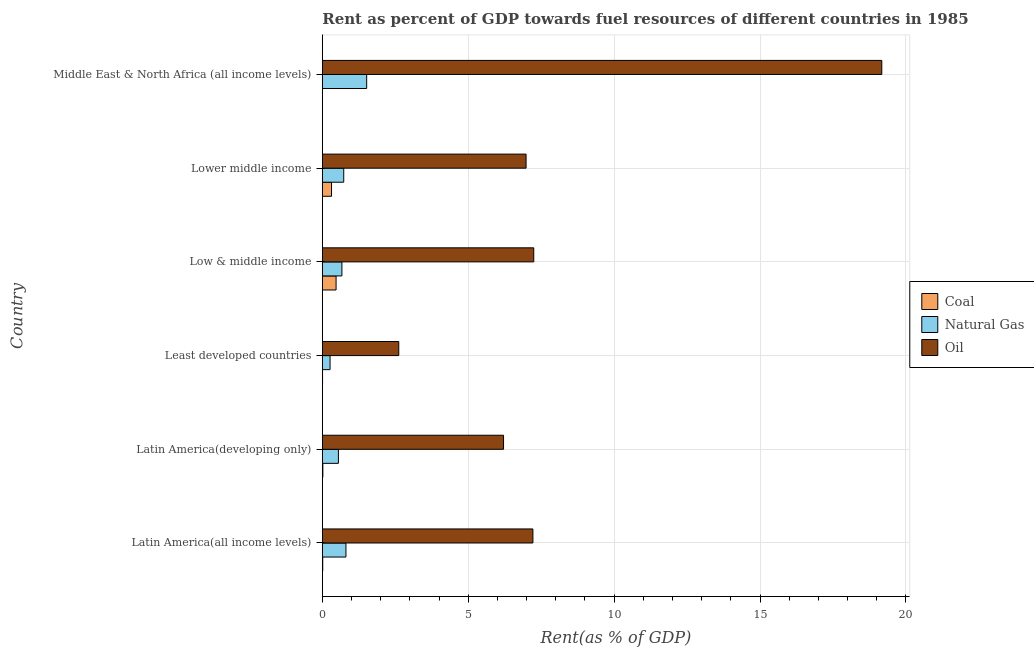Are the number of bars per tick equal to the number of legend labels?
Provide a succinct answer. Yes. Are the number of bars on each tick of the Y-axis equal?
Ensure brevity in your answer.  Yes. How many bars are there on the 5th tick from the top?
Offer a very short reply. 3. What is the label of the 5th group of bars from the top?
Provide a short and direct response. Latin America(developing only). What is the rent towards oil in Middle East & North Africa (all income levels)?
Keep it short and to the point. 19.17. Across all countries, what is the maximum rent towards coal?
Offer a very short reply. 0.47. Across all countries, what is the minimum rent towards coal?
Your response must be concise. 0. In which country was the rent towards natural gas maximum?
Offer a very short reply. Middle East & North Africa (all income levels). In which country was the rent towards oil minimum?
Provide a short and direct response. Least developed countries. What is the total rent towards coal in the graph?
Offer a terse response. 0.83. What is the difference between the rent towards oil in Latin America(all income levels) and that in Lower middle income?
Make the answer very short. 0.23. What is the difference between the rent towards natural gas in Low & middle income and the rent towards oil in Least developed countries?
Make the answer very short. -1.95. What is the average rent towards coal per country?
Your response must be concise. 0.14. What is the difference between the rent towards natural gas and rent towards coal in Latin America(developing only)?
Make the answer very short. 0.53. What is the ratio of the rent towards coal in Latin America(developing only) to that in Low & middle income?
Your answer should be compact. 0.04. Is the rent towards coal in Latin America(all income levels) less than that in Low & middle income?
Your answer should be very brief. Yes. Is the difference between the rent towards natural gas in Latin America(all income levels) and Lower middle income greater than the difference between the rent towards oil in Latin America(all income levels) and Lower middle income?
Provide a succinct answer. No. What is the difference between the highest and the second highest rent towards coal?
Make the answer very short. 0.16. In how many countries, is the rent towards coal greater than the average rent towards coal taken over all countries?
Your answer should be compact. 2. Is the sum of the rent towards coal in Latin America(all income levels) and Low & middle income greater than the maximum rent towards oil across all countries?
Your answer should be very brief. No. What does the 2nd bar from the top in Low & middle income represents?
Offer a terse response. Natural Gas. What does the 2nd bar from the bottom in Least developed countries represents?
Offer a very short reply. Natural Gas. How many bars are there?
Provide a succinct answer. 18. Are all the bars in the graph horizontal?
Offer a very short reply. Yes. How many countries are there in the graph?
Provide a short and direct response. 6. What is the difference between two consecutive major ticks on the X-axis?
Offer a terse response. 5. What is the title of the graph?
Your answer should be very brief. Rent as percent of GDP towards fuel resources of different countries in 1985. Does "Transport equipments" appear as one of the legend labels in the graph?
Ensure brevity in your answer.  No. What is the label or title of the X-axis?
Your response must be concise. Rent(as % of GDP). What is the label or title of the Y-axis?
Ensure brevity in your answer.  Country. What is the Rent(as % of GDP) in Coal in Latin America(all income levels)?
Give a very brief answer. 0.01. What is the Rent(as % of GDP) of Natural Gas in Latin America(all income levels)?
Your response must be concise. 0.81. What is the Rent(as % of GDP) of Oil in Latin America(all income levels)?
Your answer should be compact. 7.22. What is the Rent(as % of GDP) of Coal in Latin America(developing only)?
Give a very brief answer. 0.02. What is the Rent(as % of GDP) in Natural Gas in Latin America(developing only)?
Provide a succinct answer. 0.55. What is the Rent(as % of GDP) of Oil in Latin America(developing only)?
Ensure brevity in your answer.  6.21. What is the Rent(as % of GDP) of Coal in Least developed countries?
Your answer should be compact. 0.01. What is the Rent(as % of GDP) in Natural Gas in Least developed countries?
Ensure brevity in your answer.  0.27. What is the Rent(as % of GDP) of Oil in Least developed countries?
Offer a very short reply. 2.62. What is the Rent(as % of GDP) of Coal in Low & middle income?
Your response must be concise. 0.47. What is the Rent(as % of GDP) of Natural Gas in Low & middle income?
Offer a very short reply. 0.67. What is the Rent(as % of GDP) of Oil in Low & middle income?
Your answer should be compact. 7.25. What is the Rent(as % of GDP) in Coal in Lower middle income?
Offer a very short reply. 0.32. What is the Rent(as % of GDP) in Natural Gas in Lower middle income?
Provide a short and direct response. 0.73. What is the Rent(as % of GDP) of Oil in Lower middle income?
Give a very brief answer. 6.98. What is the Rent(as % of GDP) of Coal in Middle East & North Africa (all income levels)?
Your response must be concise. 0. What is the Rent(as % of GDP) in Natural Gas in Middle East & North Africa (all income levels)?
Keep it short and to the point. 1.52. What is the Rent(as % of GDP) in Oil in Middle East & North Africa (all income levels)?
Give a very brief answer. 19.17. Across all countries, what is the maximum Rent(as % of GDP) in Coal?
Your answer should be compact. 0.47. Across all countries, what is the maximum Rent(as % of GDP) of Natural Gas?
Provide a short and direct response. 1.52. Across all countries, what is the maximum Rent(as % of GDP) of Oil?
Give a very brief answer. 19.17. Across all countries, what is the minimum Rent(as % of GDP) in Coal?
Provide a succinct answer. 0. Across all countries, what is the minimum Rent(as % of GDP) of Natural Gas?
Offer a terse response. 0.27. Across all countries, what is the minimum Rent(as % of GDP) of Oil?
Your response must be concise. 2.62. What is the total Rent(as % of GDP) of Coal in the graph?
Offer a very short reply. 0.83. What is the total Rent(as % of GDP) of Natural Gas in the graph?
Give a very brief answer. 4.55. What is the total Rent(as % of GDP) of Oil in the graph?
Keep it short and to the point. 49.45. What is the difference between the Rent(as % of GDP) of Coal in Latin America(all income levels) and that in Latin America(developing only)?
Offer a very short reply. -0. What is the difference between the Rent(as % of GDP) in Natural Gas in Latin America(all income levels) and that in Latin America(developing only)?
Give a very brief answer. 0.26. What is the difference between the Rent(as % of GDP) of Oil in Latin America(all income levels) and that in Latin America(developing only)?
Provide a short and direct response. 1.01. What is the difference between the Rent(as % of GDP) of Coal in Latin America(all income levels) and that in Least developed countries?
Keep it short and to the point. 0.01. What is the difference between the Rent(as % of GDP) in Natural Gas in Latin America(all income levels) and that in Least developed countries?
Give a very brief answer. 0.54. What is the difference between the Rent(as % of GDP) in Oil in Latin America(all income levels) and that in Least developed countries?
Keep it short and to the point. 4.6. What is the difference between the Rent(as % of GDP) in Coal in Latin America(all income levels) and that in Low & middle income?
Make the answer very short. -0.46. What is the difference between the Rent(as % of GDP) in Natural Gas in Latin America(all income levels) and that in Low & middle income?
Your answer should be compact. 0.14. What is the difference between the Rent(as % of GDP) of Oil in Latin America(all income levels) and that in Low & middle income?
Offer a terse response. -0.03. What is the difference between the Rent(as % of GDP) in Coal in Latin America(all income levels) and that in Lower middle income?
Provide a short and direct response. -0.3. What is the difference between the Rent(as % of GDP) of Natural Gas in Latin America(all income levels) and that in Lower middle income?
Provide a short and direct response. 0.08. What is the difference between the Rent(as % of GDP) of Oil in Latin America(all income levels) and that in Lower middle income?
Give a very brief answer. 0.23. What is the difference between the Rent(as % of GDP) of Coal in Latin America(all income levels) and that in Middle East & North Africa (all income levels)?
Provide a short and direct response. 0.01. What is the difference between the Rent(as % of GDP) in Natural Gas in Latin America(all income levels) and that in Middle East & North Africa (all income levels)?
Keep it short and to the point. -0.71. What is the difference between the Rent(as % of GDP) in Oil in Latin America(all income levels) and that in Middle East & North Africa (all income levels)?
Your response must be concise. -11.96. What is the difference between the Rent(as % of GDP) in Coal in Latin America(developing only) and that in Least developed countries?
Provide a succinct answer. 0.01. What is the difference between the Rent(as % of GDP) in Natural Gas in Latin America(developing only) and that in Least developed countries?
Offer a terse response. 0.29. What is the difference between the Rent(as % of GDP) in Oil in Latin America(developing only) and that in Least developed countries?
Give a very brief answer. 3.59. What is the difference between the Rent(as % of GDP) of Coal in Latin America(developing only) and that in Low & middle income?
Your response must be concise. -0.45. What is the difference between the Rent(as % of GDP) in Natural Gas in Latin America(developing only) and that in Low & middle income?
Provide a succinct answer. -0.12. What is the difference between the Rent(as % of GDP) in Oil in Latin America(developing only) and that in Low & middle income?
Keep it short and to the point. -1.03. What is the difference between the Rent(as % of GDP) in Coal in Latin America(developing only) and that in Lower middle income?
Give a very brief answer. -0.3. What is the difference between the Rent(as % of GDP) of Natural Gas in Latin America(developing only) and that in Lower middle income?
Offer a very short reply. -0.18. What is the difference between the Rent(as % of GDP) of Oil in Latin America(developing only) and that in Lower middle income?
Ensure brevity in your answer.  -0.77. What is the difference between the Rent(as % of GDP) in Coal in Latin America(developing only) and that in Middle East & North Africa (all income levels)?
Keep it short and to the point. 0.01. What is the difference between the Rent(as % of GDP) of Natural Gas in Latin America(developing only) and that in Middle East & North Africa (all income levels)?
Give a very brief answer. -0.97. What is the difference between the Rent(as % of GDP) of Oil in Latin America(developing only) and that in Middle East & North Africa (all income levels)?
Your response must be concise. -12.96. What is the difference between the Rent(as % of GDP) of Coal in Least developed countries and that in Low & middle income?
Offer a very short reply. -0.46. What is the difference between the Rent(as % of GDP) of Natural Gas in Least developed countries and that in Low & middle income?
Ensure brevity in your answer.  -0.41. What is the difference between the Rent(as % of GDP) in Oil in Least developed countries and that in Low & middle income?
Your answer should be very brief. -4.63. What is the difference between the Rent(as % of GDP) of Coal in Least developed countries and that in Lower middle income?
Make the answer very short. -0.31. What is the difference between the Rent(as % of GDP) in Natural Gas in Least developed countries and that in Lower middle income?
Ensure brevity in your answer.  -0.47. What is the difference between the Rent(as % of GDP) of Oil in Least developed countries and that in Lower middle income?
Offer a very short reply. -4.36. What is the difference between the Rent(as % of GDP) of Coal in Least developed countries and that in Middle East & North Africa (all income levels)?
Give a very brief answer. 0. What is the difference between the Rent(as % of GDP) in Natural Gas in Least developed countries and that in Middle East & North Africa (all income levels)?
Keep it short and to the point. -1.25. What is the difference between the Rent(as % of GDP) in Oil in Least developed countries and that in Middle East & North Africa (all income levels)?
Your answer should be compact. -16.55. What is the difference between the Rent(as % of GDP) in Coal in Low & middle income and that in Lower middle income?
Offer a very short reply. 0.16. What is the difference between the Rent(as % of GDP) in Natural Gas in Low & middle income and that in Lower middle income?
Your answer should be compact. -0.06. What is the difference between the Rent(as % of GDP) of Oil in Low & middle income and that in Lower middle income?
Offer a very short reply. 0.26. What is the difference between the Rent(as % of GDP) of Coal in Low & middle income and that in Middle East & North Africa (all income levels)?
Keep it short and to the point. 0.47. What is the difference between the Rent(as % of GDP) of Natural Gas in Low & middle income and that in Middle East & North Africa (all income levels)?
Give a very brief answer. -0.85. What is the difference between the Rent(as % of GDP) in Oil in Low & middle income and that in Middle East & North Africa (all income levels)?
Provide a succinct answer. -11.93. What is the difference between the Rent(as % of GDP) in Coal in Lower middle income and that in Middle East & North Africa (all income levels)?
Give a very brief answer. 0.31. What is the difference between the Rent(as % of GDP) in Natural Gas in Lower middle income and that in Middle East & North Africa (all income levels)?
Give a very brief answer. -0.79. What is the difference between the Rent(as % of GDP) of Oil in Lower middle income and that in Middle East & North Africa (all income levels)?
Provide a short and direct response. -12.19. What is the difference between the Rent(as % of GDP) in Coal in Latin America(all income levels) and the Rent(as % of GDP) in Natural Gas in Latin America(developing only)?
Offer a terse response. -0.54. What is the difference between the Rent(as % of GDP) of Coal in Latin America(all income levels) and the Rent(as % of GDP) of Oil in Latin America(developing only)?
Make the answer very short. -6.2. What is the difference between the Rent(as % of GDP) in Natural Gas in Latin America(all income levels) and the Rent(as % of GDP) in Oil in Latin America(developing only)?
Offer a very short reply. -5.4. What is the difference between the Rent(as % of GDP) in Coal in Latin America(all income levels) and the Rent(as % of GDP) in Natural Gas in Least developed countries?
Offer a very short reply. -0.25. What is the difference between the Rent(as % of GDP) in Coal in Latin America(all income levels) and the Rent(as % of GDP) in Oil in Least developed countries?
Your response must be concise. -2.61. What is the difference between the Rent(as % of GDP) in Natural Gas in Latin America(all income levels) and the Rent(as % of GDP) in Oil in Least developed countries?
Provide a short and direct response. -1.81. What is the difference between the Rent(as % of GDP) of Coal in Latin America(all income levels) and the Rent(as % of GDP) of Natural Gas in Low & middle income?
Offer a terse response. -0.66. What is the difference between the Rent(as % of GDP) in Coal in Latin America(all income levels) and the Rent(as % of GDP) in Oil in Low & middle income?
Make the answer very short. -7.23. What is the difference between the Rent(as % of GDP) in Natural Gas in Latin America(all income levels) and the Rent(as % of GDP) in Oil in Low & middle income?
Your response must be concise. -6.44. What is the difference between the Rent(as % of GDP) of Coal in Latin America(all income levels) and the Rent(as % of GDP) of Natural Gas in Lower middle income?
Provide a succinct answer. -0.72. What is the difference between the Rent(as % of GDP) in Coal in Latin America(all income levels) and the Rent(as % of GDP) in Oil in Lower middle income?
Provide a short and direct response. -6.97. What is the difference between the Rent(as % of GDP) of Natural Gas in Latin America(all income levels) and the Rent(as % of GDP) of Oil in Lower middle income?
Offer a very short reply. -6.17. What is the difference between the Rent(as % of GDP) in Coal in Latin America(all income levels) and the Rent(as % of GDP) in Natural Gas in Middle East & North Africa (all income levels)?
Make the answer very short. -1.51. What is the difference between the Rent(as % of GDP) in Coal in Latin America(all income levels) and the Rent(as % of GDP) in Oil in Middle East & North Africa (all income levels)?
Make the answer very short. -19.16. What is the difference between the Rent(as % of GDP) in Natural Gas in Latin America(all income levels) and the Rent(as % of GDP) in Oil in Middle East & North Africa (all income levels)?
Give a very brief answer. -18.36. What is the difference between the Rent(as % of GDP) in Coal in Latin America(developing only) and the Rent(as % of GDP) in Natural Gas in Least developed countries?
Your response must be concise. -0.25. What is the difference between the Rent(as % of GDP) of Coal in Latin America(developing only) and the Rent(as % of GDP) of Oil in Least developed countries?
Provide a succinct answer. -2.6. What is the difference between the Rent(as % of GDP) in Natural Gas in Latin America(developing only) and the Rent(as % of GDP) in Oil in Least developed countries?
Ensure brevity in your answer.  -2.07. What is the difference between the Rent(as % of GDP) in Coal in Latin America(developing only) and the Rent(as % of GDP) in Natural Gas in Low & middle income?
Provide a succinct answer. -0.65. What is the difference between the Rent(as % of GDP) of Coal in Latin America(developing only) and the Rent(as % of GDP) of Oil in Low & middle income?
Provide a succinct answer. -7.23. What is the difference between the Rent(as % of GDP) in Natural Gas in Latin America(developing only) and the Rent(as % of GDP) in Oil in Low & middle income?
Keep it short and to the point. -6.69. What is the difference between the Rent(as % of GDP) in Coal in Latin America(developing only) and the Rent(as % of GDP) in Natural Gas in Lower middle income?
Ensure brevity in your answer.  -0.72. What is the difference between the Rent(as % of GDP) in Coal in Latin America(developing only) and the Rent(as % of GDP) in Oil in Lower middle income?
Provide a succinct answer. -6.96. What is the difference between the Rent(as % of GDP) of Natural Gas in Latin America(developing only) and the Rent(as % of GDP) of Oil in Lower middle income?
Offer a very short reply. -6.43. What is the difference between the Rent(as % of GDP) of Coal in Latin America(developing only) and the Rent(as % of GDP) of Natural Gas in Middle East & North Africa (all income levels)?
Offer a terse response. -1.5. What is the difference between the Rent(as % of GDP) in Coal in Latin America(developing only) and the Rent(as % of GDP) in Oil in Middle East & North Africa (all income levels)?
Your answer should be very brief. -19.15. What is the difference between the Rent(as % of GDP) of Natural Gas in Latin America(developing only) and the Rent(as % of GDP) of Oil in Middle East & North Africa (all income levels)?
Make the answer very short. -18.62. What is the difference between the Rent(as % of GDP) of Coal in Least developed countries and the Rent(as % of GDP) of Natural Gas in Low & middle income?
Give a very brief answer. -0.66. What is the difference between the Rent(as % of GDP) of Coal in Least developed countries and the Rent(as % of GDP) of Oil in Low & middle income?
Your response must be concise. -7.24. What is the difference between the Rent(as % of GDP) in Natural Gas in Least developed countries and the Rent(as % of GDP) in Oil in Low & middle income?
Your response must be concise. -6.98. What is the difference between the Rent(as % of GDP) of Coal in Least developed countries and the Rent(as % of GDP) of Natural Gas in Lower middle income?
Offer a very short reply. -0.73. What is the difference between the Rent(as % of GDP) in Coal in Least developed countries and the Rent(as % of GDP) in Oil in Lower middle income?
Provide a succinct answer. -6.97. What is the difference between the Rent(as % of GDP) in Natural Gas in Least developed countries and the Rent(as % of GDP) in Oil in Lower middle income?
Offer a very short reply. -6.72. What is the difference between the Rent(as % of GDP) in Coal in Least developed countries and the Rent(as % of GDP) in Natural Gas in Middle East & North Africa (all income levels)?
Provide a short and direct response. -1.51. What is the difference between the Rent(as % of GDP) in Coal in Least developed countries and the Rent(as % of GDP) in Oil in Middle East & North Africa (all income levels)?
Give a very brief answer. -19.17. What is the difference between the Rent(as % of GDP) of Natural Gas in Least developed countries and the Rent(as % of GDP) of Oil in Middle East & North Africa (all income levels)?
Offer a very short reply. -18.91. What is the difference between the Rent(as % of GDP) of Coal in Low & middle income and the Rent(as % of GDP) of Natural Gas in Lower middle income?
Provide a short and direct response. -0.26. What is the difference between the Rent(as % of GDP) in Coal in Low & middle income and the Rent(as % of GDP) in Oil in Lower middle income?
Provide a succinct answer. -6.51. What is the difference between the Rent(as % of GDP) in Natural Gas in Low & middle income and the Rent(as % of GDP) in Oil in Lower middle income?
Offer a very short reply. -6.31. What is the difference between the Rent(as % of GDP) of Coal in Low & middle income and the Rent(as % of GDP) of Natural Gas in Middle East & North Africa (all income levels)?
Your response must be concise. -1.05. What is the difference between the Rent(as % of GDP) of Coal in Low & middle income and the Rent(as % of GDP) of Oil in Middle East & North Africa (all income levels)?
Offer a terse response. -18.7. What is the difference between the Rent(as % of GDP) of Natural Gas in Low & middle income and the Rent(as % of GDP) of Oil in Middle East & North Africa (all income levels)?
Your answer should be very brief. -18.5. What is the difference between the Rent(as % of GDP) in Coal in Lower middle income and the Rent(as % of GDP) in Natural Gas in Middle East & North Africa (all income levels)?
Provide a short and direct response. -1.2. What is the difference between the Rent(as % of GDP) of Coal in Lower middle income and the Rent(as % of GDP) of Oil in Middle East & North Africa (all income levels)?
Offer a very short reply. -18.86. What is the difference between the Rent(as % of GDP) in Natural Gas in Lower middle income and the Rent(as % of GDP) in Oil in Middle East & North Africa (all income levels)?
Your answer should be compact. -18.44. What is the average Rent(as % of GDP) in Coal per country?
Give a very brief answer. 0.14. What is the average Rent(as % of GDP) in Natural Gas per country?
Give a very brief answer. 0.76. What is the average Rent(as % of GDP) in Oil per country?
Offer a very short reply. 8.24. What is the difference between the Rent(as % of GDP) in Coal and Rent(as % of GDP) in Natural Gas in Latin America(all income levels)?
Give a very brief answer. -0.8. What is the difference between the Rent(as % of GDP) of Coal and Rent(as % of GDP) of Oil in Latin America(all income levels)?
Keep it short and to the point. -7.2. What is the difference between the Rent(as % of GDP) of Natural Gas and Rent(as % of GDP) of Oil in Latin America(all income levels)?
Your answer should be very brief. -6.41. What is the difference between the Rent(as % of GDP) of Coal and Rent(as % of GDP) of Natural Gas in Latin America(developing only)?
Make the answer very short. -0.53. What is the difference between the Rent(as % of GDP) in Coal and Rent(as % of GDP) in Oil in Latin America(developing only)?
Offer a very short reply. -6.19. What is the difference between the Rent(as % of GDP) of Natural Gas and Rent(as % of GDP) of Oil in Latin America(developing only)?
Keep it short and to the point. -5.66. What is the difference between the Rent(as % of GDP) in Coal and Rent(as % of GDP) in Natural Gas in Least developed countries?
Make the answer very short. -0.26. What is the difference between the Rent(as % of GDP) of Coal and Rent(as % of GDP) of Oil in Least developed countries?
Your answer should be compact. -2.61. What is the difference between the Rent(as % of GDP) of Natural Gas and Rent(as % of GDP) of Oil in Least developed countries?
Give a very brief answer. -2.35. What is the difference between the Rent(as % of GDP) in Coal and Rent(as % of GDP) in Natural Gas in Low & middle income?
Keep it short and to the point. -0.2. What is the difference between the Rent(as % of GDP) of Coal and Rent(as % of GDP) of Oil in Low & middle income?
Give a very brief answer. -6.77. What is the difference between the Rent(as % of GDP) of Natural Gas and Rent(as % of GDP) of Oil in Low & middle income?
Your response must be concise. -6.57. What is the difference between the Rent(as % of GDP) in Coal and Rent(as % of GDP) in Natural Gas in Lower middle income?
Offer a very short reply. -0.42. What is the difference between the Rent(as % of GDP) in Coal and Rent(as % of GDP) in Oil in Lower middle income?
Your answer should be compact. -6.67. What is the difference between the Rent(as % of GDP) of Natural Gas and Rent(as % of GDP) of Oil in Lower middle income?
Provide a succinct answer. -6.25. What is the difference between the Rent(as % of GDP) in Coal and Rent(as % of GDP) in Natural Gas in Middle East & North Africa (all income levels)?
Your answer should be compact. -1.52. What is the difference between the Rent(as % of GDP) of Coal and Rent(as % of GDP) of Oil in Middle East & North Africa (all income levels)?
Offer a very short reply. -19.17. What is the difference between the Rent(as % of GDP) of Natural Gas and Rent(as % of GDP) of Oil in Middle East & North Africa (all income levels)?
Make the answer very short. -17.65. What is the ratio of the Rent(as % of GDP) in Coal in Latin America(all income levels) to that in Latin America(developing only)?
Ensure brevity in your answer.  0.76. What is the ratio of the Rent(as % of GDP) of Natural Gas in Latin America(all income levels) to that in Latin America(developing only)?
Offer a terse response. 1.47. What is the ratio of the Rent(as % of GDP) of Oil in Latin America(all income levels) to that in Latin America(developing only)?
Your answer should be compact. 1.16. What is the ratio of the Rent(as % of GDP) of Coal in Latin America(all income levels) to that in Least developed countries?
Your response must be concise. 1.86. What is the ratio of the Rent(as % of GDP) in Natural Gas in Latin America(all income levels) to that in Least developed countries?
Provide a short and direct response. 3.05. What is the ratio of the Rent(as % of GDP) in Oil in Latin America(all income levels) to that in Least developed countries?
Your response must be concise. 2.76. What is the ratio of the Rent(as % of GDP) in Coal in Latin America(all income levels) to that in Low & middle income?
Offer a terse response. 0.03. What is the ratio of the Rent(as % of GDP) in Natural Gas in Latin America(all income levels) to that in Low & middle income?
Give a very brief answer. 1.21. What is the ratio of the Rent(as % of GDP) of Coal in Latin America(all income levels) to that in Lower middle income?
Your response must be concise. 0.04. What is the ratio of the Rent(as % of GDP) of Natural Gas in Latin America(all income levels) to that in Lower middle income?
Provide a short and direct response. 1.1. What is the ratio of the Rent(as % of GDP) in Oil in Latin America(all income levels) to that in Lower middle income?
Keep it short and to the point. 1.03. What is the ratio of the Rent(as % of GDP) in Coal in Latin America(all income levels) to that in Middle East & North Africa (all income levels)?
Provide a succinct answer. 3.24. What is the ratio of the Rent(as % of GDP) in Natural Gas in Latin America(all income levels) to that in Middle East & North Africa (all income levels)?
Your answer should be compact. 0.53. What is the ratio of the Rent(as % of GDP) in Oil in Latin America(all income levels) to that in Middle East & North Africa (all income levels)?
Keep it short and to the point. 0.38. What is the ratio of the Rent(as % of GDP) of Coal in Latin America(developing only) to that in Least developed countries?
Offer a terse response. 2.45. What is the ratio of the Rent(as % of GDP) in Natural Gas in Latin America(developing only) to that in Least developed countries?
Your answer should be very brief. 2.08. What is the ratio of the Rent(as % of GDP) of Oil in Latin America(developing only) to that in Least developed countries?
Provide a short and direct response. 2.37. What is the ratio of the Rent(as % of GDP) of Coal in Latin America(developing only) to that in Low & middle income?
Keep it short and to the point. 0.04. What is the ratio of the Rent(as % of GDP) in Natural Gas in Latin America(developing only) to that in Low & middle income?
Offer a very short reply. 0.82. What is the ratio of the Rent(as % of GDP) of Oil in Latin America(developing only) to that in Low & middle income?
Keep it short and to the point. 0.86. What is the ratio of the Rent(as % of GDP) of Coal in Latin America(developing only) to that in Lower middle income?
Provide a succinct answer. 0.06. What is the ratio of the Rent(as % of GDP) of Natural Gas in Latin America(developing only) to that in Lower middle income?
Ensure brevity in your answer.  0.75. What is the ratio of the Rent(as % of GDP) in Oil in Latin America(developing only) to that in Lower middle income?
Offer a terse response. 0.89. What is the ratio of the Rent(as % of GDP) in Coal in Latin America(developing only) to that in Middle East & North Africa (all income levels)?
Your answer should be compact. 4.28. What is the ratio of the Rent(as % of GDP) of Natural Gas in Latin America(developing only) to that in Middle East & North Africa (all income levels)?
Ensure brevity in your answer.  0.36. What is the ratio of the Rent(as % of GDP) of Oil in Latin America(developing only) to that in Middle East & North Africa (all income levels)?
Offer a very short reply. 0.32. What is the ratio of the Rent(as % of GDP) in Coal in Least developed countries to that in Low & middle income?
Make the answer very short. 0.02. What is the ratio of the Rent(as % of GDP) of Natural Gas in Least developed countries to that in Low & middle income?
Your answer should be compact. 0.4. What is the ratio of the Rent(as % of GDP) of Oil in Least developed countries to that in Low & middle income?
Provide a short and direct response. 0.36. What is the ratio of the Rent(as % of GDP) of Coal in Least developed countries to that in Lower middle income?
Give a very brief answer. 0.02. What is the ratio of the Rent(as % of GDP) in Natural Gas in Least developed countries to that in Lower middle income?
Your answer should be very brief. 0.36. What is the ratio of the Rent(as % of GDP) of Oil in Least developed countries to that in Lower middle income?
Your response must be concise. 0.38. What is the ratio of the Rent(as % of GDP) of Coal in Least developed countries to that in Middle East & North Africa (all income levels)?
Offer a terse response. 1.75. What is the ratio of the Rent(as % of GDP) in Natural Gas in Least developed countries to that in Middle East & North Africa (all income levels)?
Your answer should be compact. 0.17. What is the ratio of the Rent(as % of GDP) of Oil in Least developed countries to that in Middle East & North Africa (all income levels)?
Make the answer very short. 0.14. What is the ratio of the Rent(as % of GDP) of Coal in Low & middle income to that in Lower middle income?
Offer a terse response. 1.5. What is the ratio of the Rent(as % of GDP) of Natural Gas in Low & middle income to that in Lower middle income?
Your answer should be compact. 0.91. What is the ratio of the Rent(as % of GDP) of Oil in Low & middle income to that in Lower middle income?
Ensure brevity in your answer.  1.04. What is the ratio of the Rent(as % of GDP) of Coal in Low & middle income to that in Middle East & North Africa (all income levels)?
Offer a terse response. 111.45. What is the ratio of the Rent(as % of GDP) of Natural Gas in Low & middle income to that in Middle East & North Africa (all income levels)?
Ensure brevity in your answer.  0.44. What is the ratio of the Rent(as % of GDP) of Oil in Low & middle income to that in Middle East & North Africa (all income levels)?
Provide a succinct answer. 0.38. What is the ratio of the Rent(as % of GDP) of Coal in Lower middle income to that in Middle East & North Africa (all income levels)?
Your answer should be compact. 74.55. What is the ratio of the Rent(as % of GDP) in Natural Gas in Lower middle income to that in Middle East & North Africa (all income levels)?
Provide a succinct answer. 0.48. What is the ratio of the Rent(as % of GDP) of Oil in Lower middle income to that in Middle East & North Africa (all income levels)?
Provide a short and direct response. 0.36. What is the difference between the highest and the second highest Rent(as % of GDP) in Coal?
Give a very brief answer. 0.16. What is the difference between the highest and the second highest Rent(as % of GDP) in Natural Gas?
Offer a terse response. 0.71. What is the difference between the highest and the second highest Rent(as % of GDP) of Oil?
Ensure brevity in your answer.  11.93. What is the difference between the highest and the lowest Rent(as % of GDP) of Coal?
Offer a terse response. 0.47. What is the difference between the highest and the lowest Rent(as % of GDP) of Natural Gas?
Your answer should be very brief. 1.25. What is the difference between the highest and the lowest Rent(as % of GDP) of Oil?
Give a very brief answer. 16.55. 